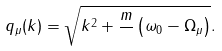<formula> <loc_0><loc_0><loc_500><loc_500>q _ { \mu } ( k ) = \sqrt { k ^ { 2 } + \frac { m } { } \left ( \omega _ { 0 } - \Omega _ { \mu } \right ) } .</formula> 